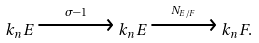<formula> <loc_0><loc_0><loc_500><loc_500>k _ { n } E \xrightarrow { \ \sigma - 1 \ } k _ { n } E \xrightarrow { N _ { E / F } } k _ { n } F .</formula> 